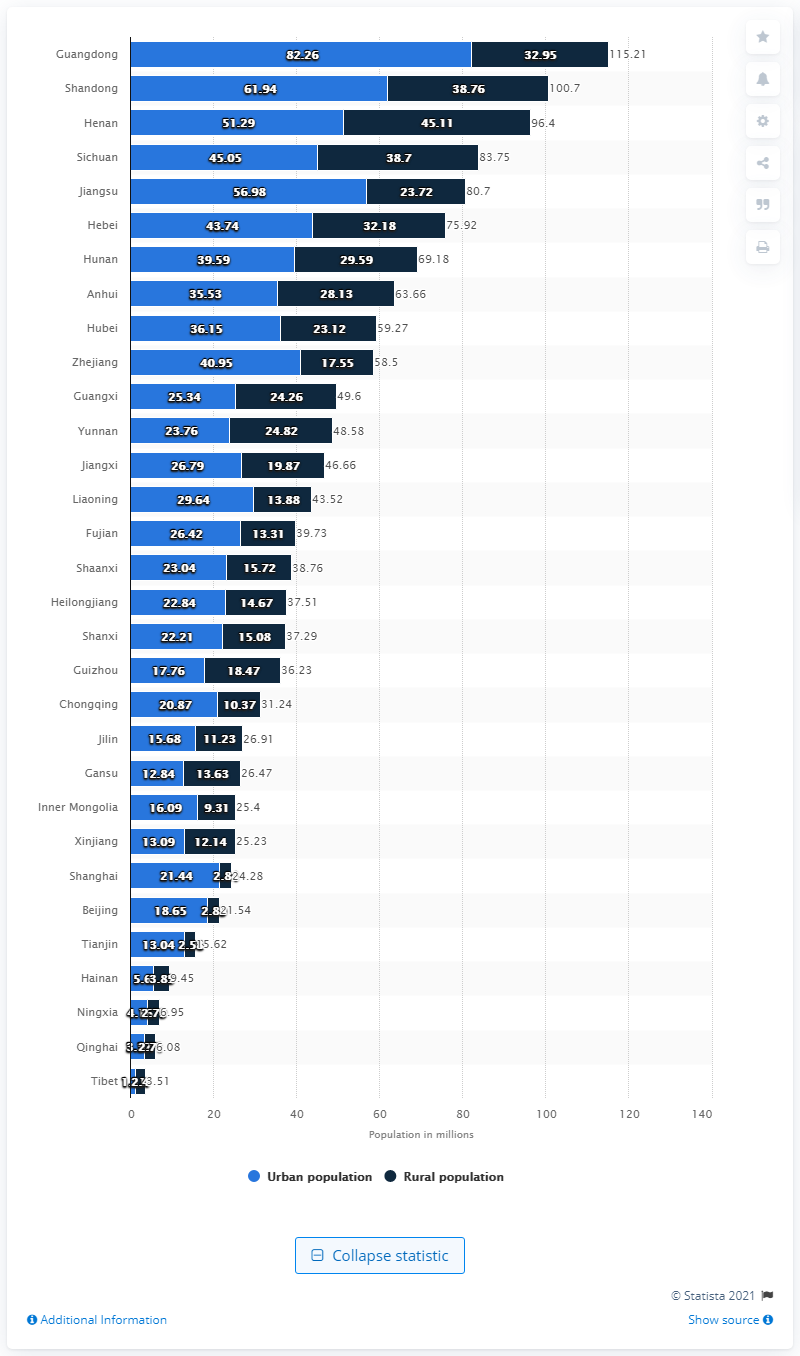List a handful of essential elements in this visual. In 2019, the rural population of Tibet was approximately 2.4 million. According to the data, in 2019, the urban population of Tibet was approximately 1.11 million. In 2019, the urban population of Tibet was approximately 1.11 million. 